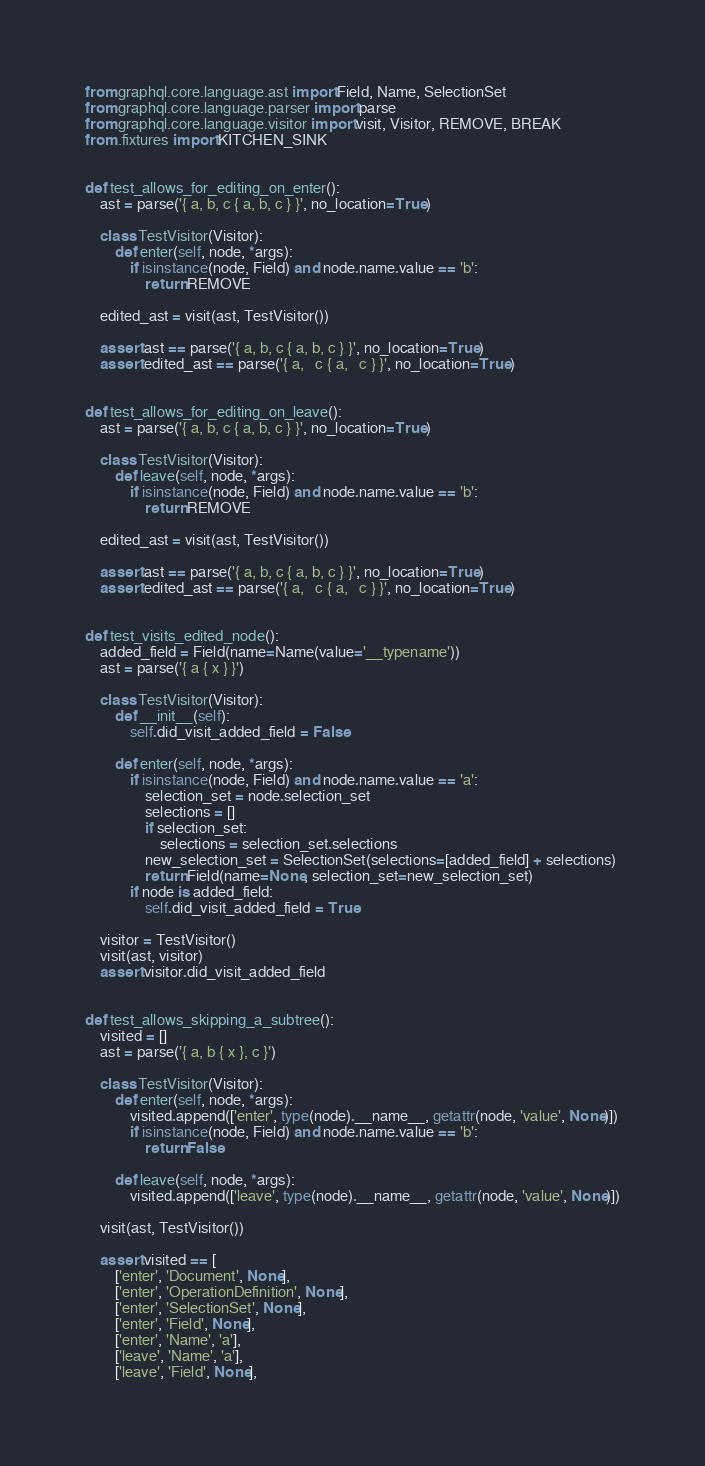Convert code to text. <code><loc_0><loc_0><loc_500><loc_500><_Python_>from graphql.core.language.ast import Field, Name, SelectionSet
from graphql.core.language.parser import parse
from graphql.core.language.visitor import visit, Visitor, REMOVE, BREAK
from .fixtures import KITCHEN_SINK


def test_allows_for_editing_on_enter():
    ast = parse('{ a, b, c { a, b, c } }', no_location=True)

    class TestVisitor(Visitor):
        def enter(self, node, *args):
            if isinstance(node, Field) and node.name.value == 'b':
                return REMOVE

    edited_ast = visit(ast, TestVisitor())

    assert ast == parse('{ a, b, c { a, b, c } }', no_location=True)
    assert edited_ast == parse('{ a,   c { a,   c } }', no_location=True)


def test_allows_for_editing_on_leave():
    ast = parse('{ a, b, c { a, b, c } }', no_location=True)

    class TestVisitor(Visitor):
        def leave(self, node, *args):
            if isinstance(node, Field) and node.name.value == 'b':
                return REMOVE

    edited_ast = visit(ast, TestVisitor())

    assert ast == parse('{ a, b, c { a, b, c } }', no_location=True)
    assert edited_ast == parse('{ a,   c { a,   c } }', no_location=True)


def test_visits_edited_node():
    added_field = Field(name=Name(value='__typename'))
    ast = parse('{ a { x } }')

    class TestVisitor(Visitor):
        def __init__(self):
            self.did_visit_added_field = False

        def enter(self, node, *args):
            if isinstance(node, Field) and node.name.value == 'a':
                selection_set = node.selection_set
                selections = []
                if selection_set:
                    selections = selection_set.selections
                new_selection_set = SelectionSet(selections=[added_field] + selections)
                return Field(name=None, selection_set=new_selection_set)
            if node is added_field:
                self.did_visit_added_field = True

    visitor = TestVisitor()
    visit(ast, visitor)
    assert visitor.did_visit_added_field


def test_allows_skipping_a_subtree():
    visited = []
    ast = parse('{ a, b { x }, c }')

    class TestVisitor(Visitor):
        def enter(self, node, *args):
            visited.append(['enter', type(node).__name__, getattr(node, 'value', None)])
            if isinstance(node, Field) and node.name.value == 'b':
                return False

        def leave(self, node, *args):
            visited.append(['leave', type(node).__name__, getattr(node, 'value', None)])

    visit(ast, TestVisitor())

    assert visited == [
        ['enter', 'Document', None],
        ['enter', 'OperationDefinition', None],
        ['enter', 'SelectionSet', None],
        ['enter', 'Field', None],
        ['enter', 'Name', 'a'],
        ['leave', 'Name', 'a'],
        ['leave', 'Field', None],</code> 